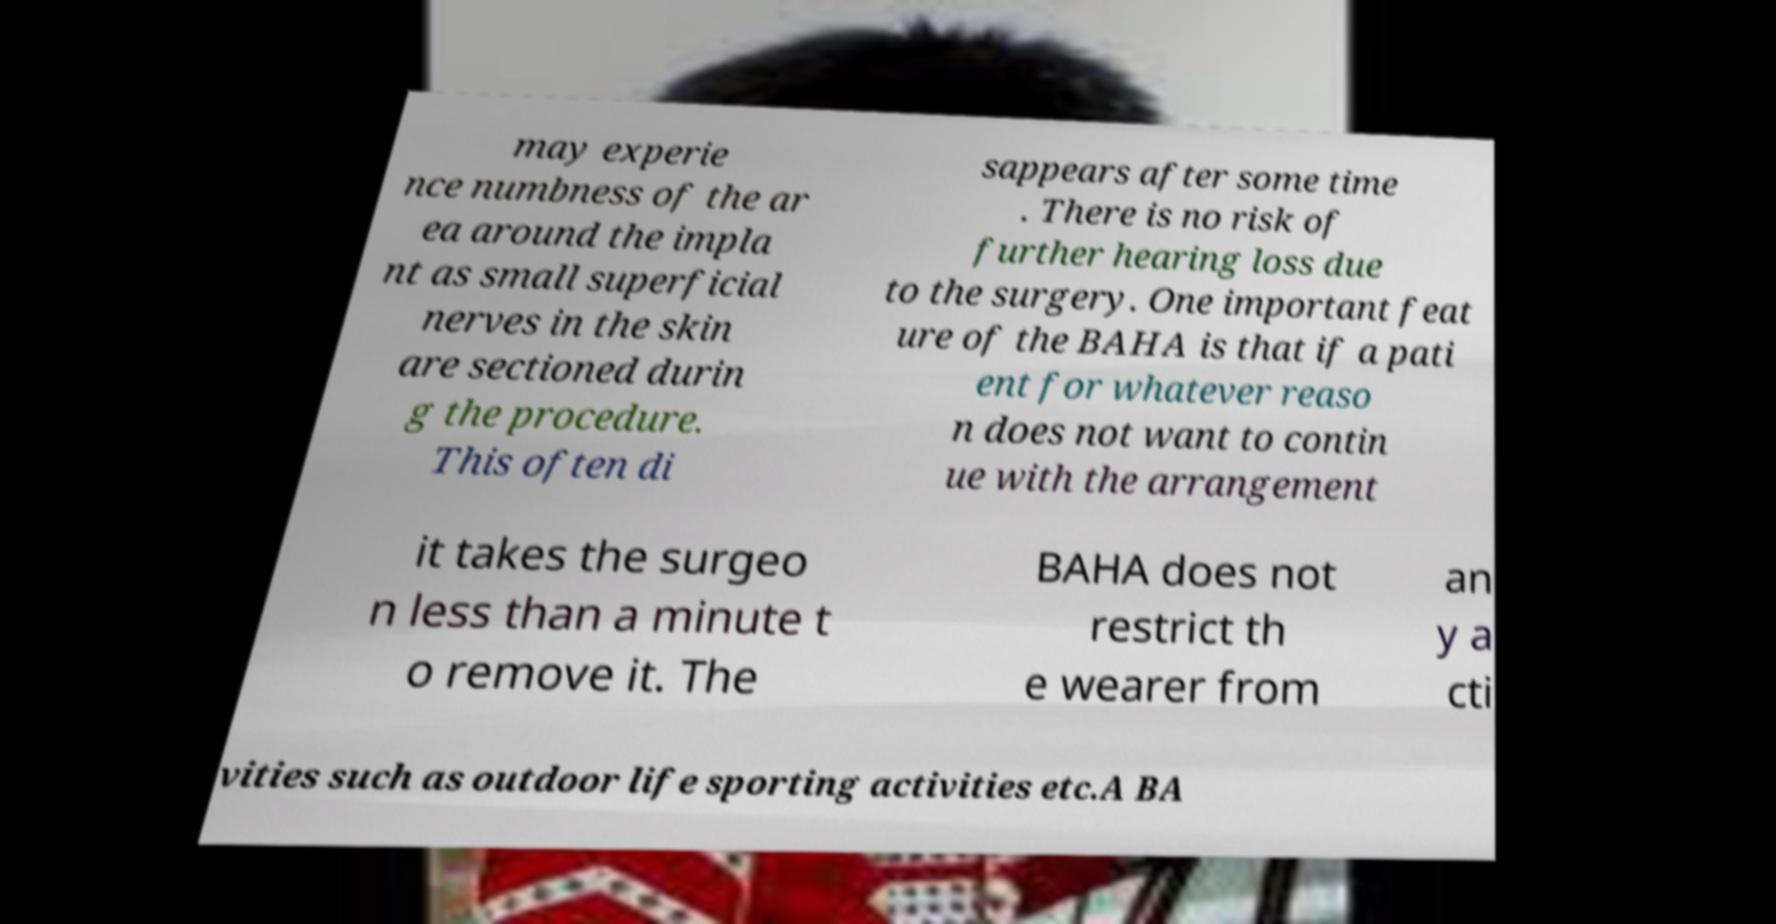Could you assist in decoding the text presented in this image and type it out clearly? may experie nce numbness of the ar ea around the impla nt as small superficial nerves in the skin are sectioned durin g the procedure. This often di sappears after some time . There is no risk of further hearing loss due to the surgery. One important feat ure of the BAHA is that if a pati ent for whatever reaso n does not want to contin ue with the arrangement it takes the surgeo n less than a minute t o remove it. The BAHA does not restrict th e wearer from an y a cti vities such as outdoor life sporting activities etc.A BA 